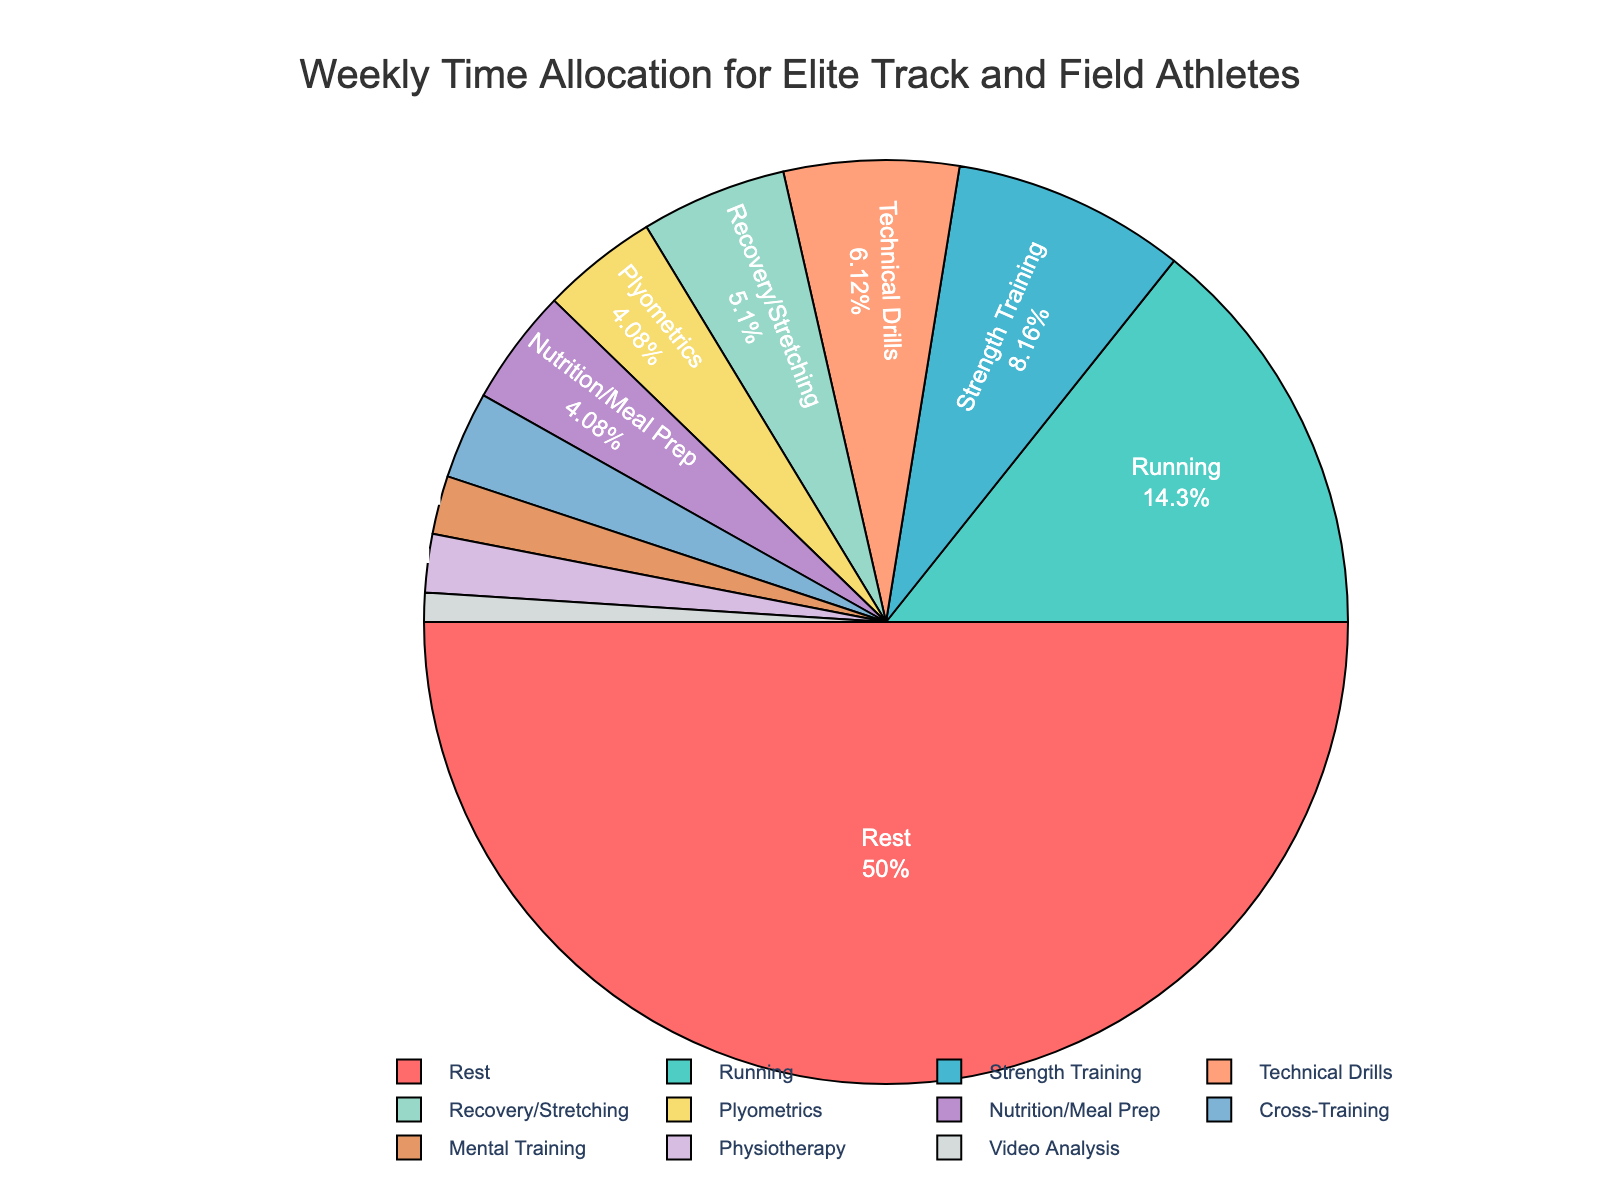What activity takes up the highest percentage of time in a typical week? The activity that takes up the highest percentage is shown with the largest section on the pie chart. By inspecting the chart, we can see that "Rest" has the largest section.
Answer: Rest Which two activities combined take up more time than Strength Training? First, identify the percentage of time spent on Strength Training, which is 8 hours. Then, look for combinations of activities whose hours sum up to more than 8. Adding hours for "Running" (14) and "Technical Drills" (6) results in 20 hours, which is more than 8.
Answer: Running and Technical Drills Which activity is allocated the least amount of time in a week? The activity with the smallest section on the pie chart represents the least amount of time allocation. "Video Analysis" has the smallest section.
Answer: Video Analysis What is the total percentage of time allocated to activities other than Rest and Running? Add up the percentages of all activities except Rest and Running. The other activities are Strength Training, Plyometrics, Technical Drills, Recovery/Stretching, Cross-Training, Nutrition/Meal Prep, Mental Training, Physiotherapy, and Video Analysis. Calculate their total percentage.
Answer: 31.65% Is the time spent on Recovery/Stretching more or less than the time spent on Cross-Training and Mental Training combined? First, check the hours spent on Recovery/Stretching, which is 5 hours. Then, check the combined hours for Cross-Training (3) and Mental Training (2), which is 5 hours. Since they are equal, the time spent on Recovery/Stretching is equal to the time spent on Cross-Training and Mental Training combined.
Answer: Equal How much more time is allocated to Running compared to Recovery/Stretching? Subtract the hours for Recovery/Stretching from the hours spent on Running. That is, 14 (Running) - 5 (Recovery/Stretching) = 9 hours.
Answer: 9 hours Which activities collectively make up exactly 10% of the total training time? Determine the activities whose combined percentage totals 10%. Mental Training (2%) and Physiotherapy (2%) combined with Cross-Training (3%) and Video Analysis (1%) form exactly 10%.
Answer: Mental Training, Physiotherapy, Cross-Training, Video Analysis What percentage of time is spent on activities not directly related to physical exercise, like Nutrition/Meal Prep and Mental Training? Add the percentage of time from Nutrition/Meal Prep (4%) and Mental Training (2%) — 4% + 2% = 6%.
Answer: 6% 